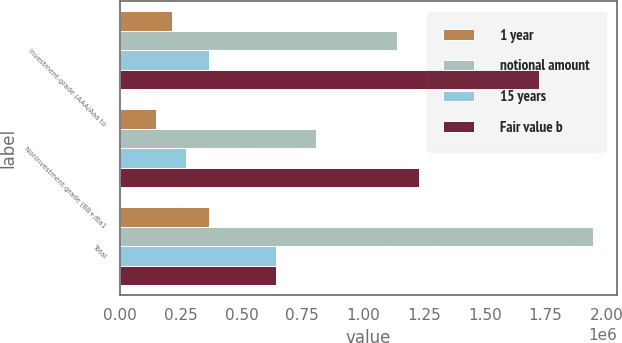Convert chart. <chart><loc_0><loc_0><loc_500><loc_500><stacked_bar_chart><ecel><fcel>Investment-grade (AAA/Aaa to<fcel>Noninvestment-grade (BB+/Ba1<fcel>Total<nl><fcel>1 year<fcel>215580<fcel>150122<fcel>365702<nl><fcel>notional amount<fcel>1.14013e+06<fcel>806139<fcel>1.94627e+06<nl><fcel>15 years<fcel>367015<fcel>273059<fcel>640074<nl><fcel>Fair value b<fcel>1.72273e+06<fcel>1.22932e+06<fcel>640074<nl></chart> 